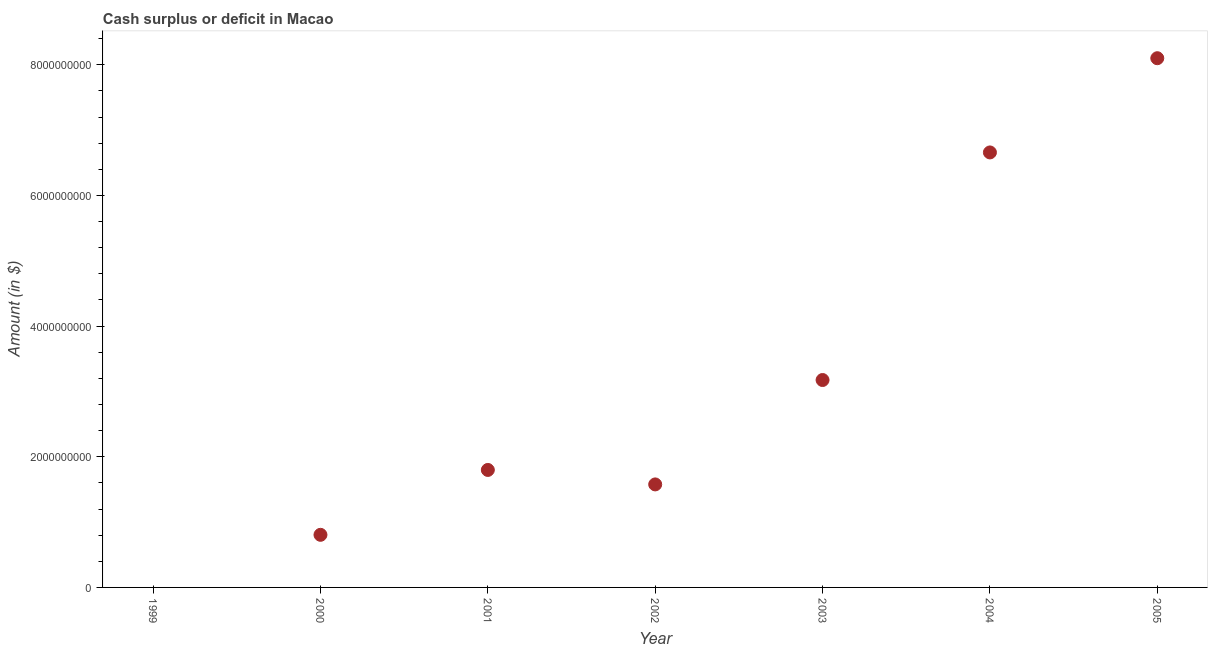What is the cash surplus or deficit in 2005?
Provide a short and direct response. 8.10e+09. Across all years, what is the maximum cash surplus or deficit?
Your response must be concise. 8.10e+09. In which year was the cash surplus or deficit maximum?
Your answer should be compact. 2005. What is the sum of the cash surplus or deficit?
Provide a succinct answer. 2.21e+1. What is the difference between the cash surplus or deficit in 2000 and 2005?
Your answer should be very brief. -7.29e+09. What is the average cash surplus or deficit per year?
Offer a terse response. 3.16e+09. What is the median cash surplus or deficit?
Your response must be concise. 1.80e+09. In how many years, is the cash surplus or deficit greater than 400000000 $?
Offer a terse response. 6. What is the ratio of the cash surplus or deficit in 2000 to that in 2003?
Ensure brevity in your answer.  0.25. Is the cash surplus or deficit in 2000 less than that in 2002?
Offer a terse response. Yes. Is the difference between the cash surplus or deficit in 2001 and 2004 greater than the difference between any two years?
Offer a terse response. No. What is the difference between the highest and the second highest cash surplus or deficit?
Your answer should be compact. 1.44e+09. Is the sum of the cash surplus or deficit in 2001 and 2004 greater than the maximum cash surplus or deficit across all years?
Provide a short and direct response. Yes. What is the difference between the highest and the lowest cash surplus or deficit?
Your response must be concise. 8.10e+09. In how many years, is the cash surplus or deficit greater than the average cash surplus or deficit taken over all years?
Provide a short and direct response. 3. How many dotlines are there?
Your answer should be compact. 1. How many years are there in the graph?
Offer a terse response. 7. What is the difference between two consecutive major ticks on the Y-axis?
Provide a short and direct response. 2.00e+09. Does the graph contain grids?
Provide a short and direct response. No. What is the title of the graph?
Keep it short and to the point. Cash surplus or deficit in Macao. What is the label or title of the X-axis?
Give a very brief answer. Year. What is the label or title of the Y-axis?
Your answer should be compact. Amount (in $). What is the Amount (in $) in 1999?
Your answer should be very brief. 0. What is the Amount (in $) in 2000?
Give a very brief answer. 8.05e+08. What is the Amount (in $) in 2001?
Offer a terse response. 1.80e+09. What is the Amount (in $) in 2002?
Provide a succinct answer. 1.58e+09. What is the Amount (in $) in 2003?
Keep it short and to the point. 3.17e+09. What is the Amount (in $) in 2004?
Make the answer very short. 6.66e+09. What is the Amount (in $) in 2005?
Make the answer very short. 8.10e+09. What is the difference between the Amount (in $) in 2000 and 2001?
Keep it short and to the point. -9.93e+08. What is the difference between the Amount (in $) in 2000 and 2002?
Your answer should be compact. -7.72e+08. What is the difference between the Amount (in $) in 2000 and 2003?
Keep it short and to the point. -2.37e+09. What is the difference between the Amount (in $) in 2000 and 2004?
Provide a succinct answer. -5.85e+09. What is the difference between the Amount (in $) in 2000 and 2005?
Give a very brief answer. -7.29e+09. What is the difference between the Amount (in $) in 2001 and 2002?
Your answer should be very brief. 2.22e+08. What is the difference between the Amount (in $) in 2001 and 2003?
Provide a succinct answer. -1.38e+09. What is the difference between the Amount (in $) in 2001 and 2004?
Make the answer very short. -4.86e+09. What is the difference between the Amount (in $) in 2001 and 2005?
Offer a very short reply. -6.30e+09. What is the difference between the Amount (in $) in 2002 and 2003?
Ensure brevity in your answer.  -1.60e+09. What is the difference between the Amount (in $) in 2002 and 2004?
Offer a terse response. -5.08e+09. What is the difference between the Amount (in $) in 2002 and 2005?
Provide a succinct answer. -6.52e+09. What is the difference between the Amount (in $) in 2003 and 2004?
Give a very brief answer. -3.48e+09. What is the difference between the Amount (in $) in 2003 and 2005?
Keep it short and to the point. -4.93e+09. What is the difference between the Amount (in $) in 2004 and 2005?
Ensure brevity in your answer.  -1.44e+09. What is the ratio of the Amount (in $) in 2000 to that in 2001?
Ensure brevity in your answer.  0.45. What is the ratio of the Amount (in $) in 2000 to that in 2002?
Give a very brief answer. 0.51. What is the ratio of the Amount (in $) in 2000 to that in 2003?
Make the answer very short. 0.25. What is the ratio of the Amount (in $) in 2000 to that in 2004?
Your response must be concise. 0.12. What is the ratio of the Amount (in $) in 2000 to that in 2005?
Ensure brevity in your answer.  0.1. What is the ratio of the Amount (in $) in 2001 to that in 2002?
Ensure brevity in your answer.  1.14. What is the ratio of the Amount (in $) in 2001 to that in 2003?
Keep it short and to the point. 0.57. What is the ratio of the Amount (in $) in 2001 to that in 2004?
Give a very brief answer. 0.27. What is the ratio of the Amount (in $) in 2001 to that in 2005?
Your answer should be compact. 0.22. What is the ratio of the Amount (in $) in 2002 to that in 2003?
Provide a succinct answer. 0.5. What is the ratio of the Amount (in $) in 2002 to that in 2004?
Your answer should be compact. 0.24. What is the ratio of the Amount (in $) in 2002 to that in 2005?
Give a very brief answer. 0.2. What is the ratio of the Amount (in $) in 2003 to that in 2004?
Provide a short and direct response. 0.48. What is the ratio of the Amount (in $) in 2003 to that in 2005?
Your response must be concise. 0.39. What is the ratio of the Amount (in $) in 2004 to that in 2005?
Make the answer very short. 0.82. 